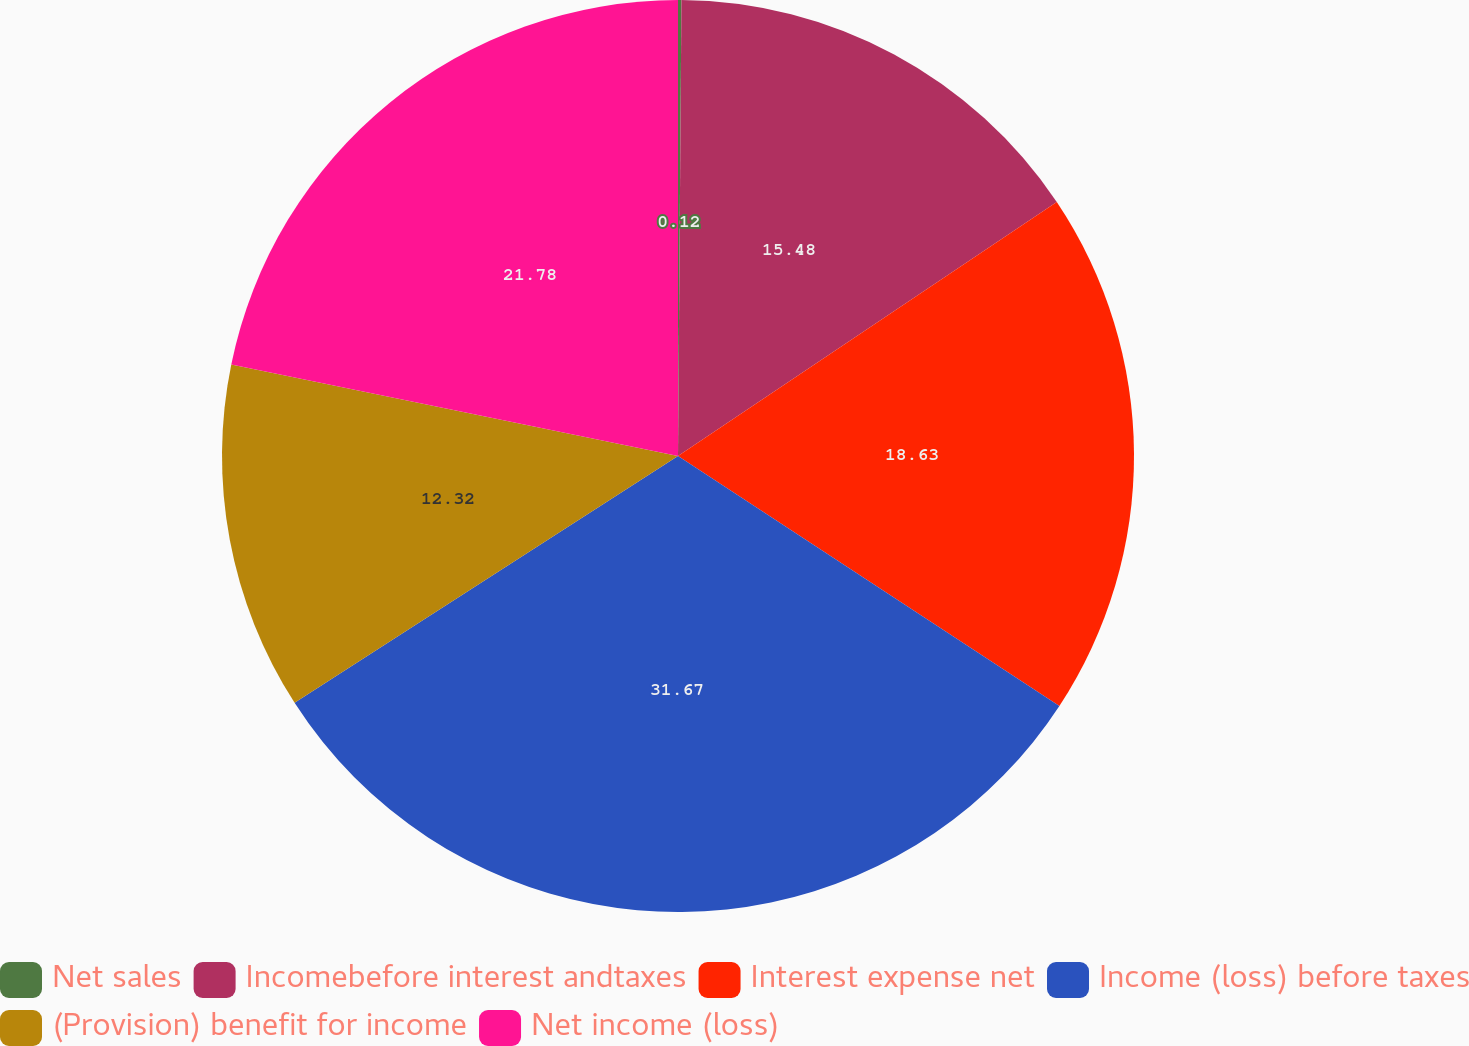Convert chart to OTSL. <chart><loc_0><loc_0><loc_500><loc_500><pie_chart><fcel>Net sales<fcel>Incomebefore interest andtaxes<fcel>Interest expense net<fcel>Income (loss) before taxes<fcel>(Provision) benefit for income<fcel>Net income (loss)<nl><fcel>0.12%<fcel>15.48%<fcel>18.63%<fcel>31.66%<fcel>12.32%<fcel>21.78%<nl></chart> 